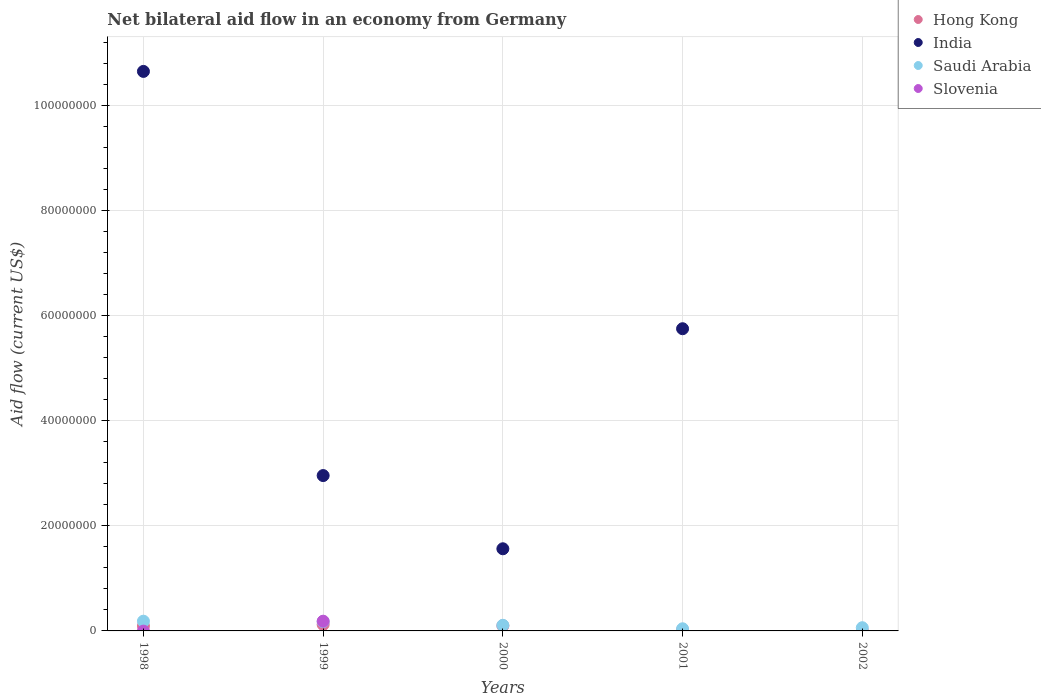What is the net bilateral aid flow in Saudi Arabia in 1998?
Offer a very short reply. 1.85e+06. Across all years, what is the maximum net bilateral aid flow in Hong Kong?
Ensure brevity in your answer.  1.22e+06. Across all years, what is the minimum net bilateral aid flow in Slovenia?
Make the answer very short. 0. What is the total net bilateral aid flow in Slovenia in the graph?
Your answer should be very brief. 1.85e+06. What is the difference between the net bilateral aid flow in Hong Kong in 1998 and that in 2002?
Keep it short and to the point. 9.10e+05. What is the difference between the net bilateral aid flow in India in 1999 and the net bilateral aid flow in Hong Kong in 2001?
Provide a succinct answer. 2.94e+07. In the year 1999, what is the difference between the net bilateral aid flow in Hong Kong and net bilateral aid flow in Slovenia?
Give a very brief answer. -6.30e+05. In how many years, is the net bilateral aid flow in India greater than 68000000 US$?
Your response must be concise. 1. What is the ratio of the net bilateral aid flow in Hong Kong in 1998 to that in 1999?
Keep it short and to the point. 0.75. Is the net bilateral aid flow in India in 1998 less than that in 1999?
Provide a short and direct response. No. What is the difference between the highest and the lowest net bilateral aid flow in Saudi Arabia?
Offer a terse response. 1.44e+06. In how many years, is the net bilateral aid flow in Hong Kong greater than the average net bilateral aid flow in Hong Kong taken over all years?
Give a very brief answer. 3. Is the sum of the net bilateral aid flow in Hong Kong in 1998 and 1999 greater than the maximum net bilateral aid flow in India across all years?
Provide a succinct answer. No. Is it the case that in every year, the sum of the net bilateral aid flow in Slovenia and net bilateral aid flow in Saudi Arabia  is greater than the sum of net bilateral aid flow in Hong Kong and net bilateral aid flow in India?
Provide a short and direct response. No. Is it the case that in every year, the sum of the net bilateral aid flow in India and net bilateral aid flow in Saudi Arabia  is greater than the net bilateral aid flow in Slovenia?
Provide a short and direct response. Yes. Is the net bilateral aid flow in Hong Kong strictly less than the net bilateral aid flow in Saudi Arabia over the years?
Make the answer very short. Yes. Are the values on the major ticks of Y-axis written in scientific E-notation?
Offer a terse response. No. Does the graph contain any zero values?
Your answer should be very brief. Yes. Does the graph contain grids?
Offer a terse response. Yes. Where does the legend appear in the graph?
Provide a short and direct response. Top right. What is the title of the graph?
Provide a succinct answer. Net bilateral aid flow in an economy from Germany. Does "Andorra" appear as one of the legend labels in the graph?
Provide a short and direct response. No. What is the Aid flow (current US$) in Hong Kong in 1998?
Your answer should be very brief. 9.20e+05. What is the Aid flow (current US$) of India in 1998?
Your response must be concise. 1.06e+08. What is the Aid flow (current US$) in Saudi Arabia in 1998?
Provide a short and direct response. 1.85e+06. What is the Aid flow (current US$) in Hong Kong in 1999?
Ensure brevity in your answer.  1.22e+06. What is the Aid flow (current US$) in India in 1999?
Provide a succinct answer. 2.96e+07. What is the Aid flow (current US$) in Saudi Arabia in 1999?
Your answer should be very brief. 1.76e+06. What is the Aid flow (current US$) in Slovenia in 1999?
Offer a very short reply. 1.85e+06. What is the Aid flow (current US$) in Hong Kong in 2000?
Ensure brevity in your answer.  9.80e+05. What is the Aid flow (current US$) in India in 2000?
Your answer should be compact. 1.56e+07. What is the Aid flow (current US$) in Saudi Arabia in 2000?
Your answer should be very brief. 1.07e+06. What is the Aid flow (current US$) in Slovenia in 2000?
Offer a terse response. 0. What is the Aid flow (current US$) in Hong Kong in 2001?
Provide a short and direct response. 1.50e+05. What is the Aid flow (current US$) of India in 2001?
Your response must be concise. 5.75e+07. What is the Aid flow (current US$) in Slovenia in 2001?
Keep it short and to the point. 0. What is the Aid flow (current US$) in Slovenia in 2002?
Your response must be concise. 0. Across all years, what is the maximum Aid flow (current US$) of Hong Kong?
Offer a very short reply. 1.22e+06. Across all years, what is the maximum Aid flow (current US$) of India?
Your answer should be compact. 1.06e+08. Across all years, what is the maximum Aid flow (current US$) of Saudi Arabia?
Offer a very short reply. 1.85e+06. Across all years, what is the maximum Aid flow (current US$) in Slovenia?
Offer a terse response. 1.85e+06. What is the total Aid flow (current US$) in Hong Kong in the graph?
Provide a succinct answer. 3.28e+06. What is the total Aid flow (current US$) of India in the graph?
Your answer should be compact. 2.09e+08. What is the total Aid flow (current US$) in Saudi Arabia in the graph?
Give a very brief answer. 5.70e+06. What is the total Aid flow (current US$) in Slovenia in the graph?
Your response must be concise. 1.85e+06. What is the difference between the Aid flow (current US$) in Hong Kong in 1998 and that in 1999?
Your answer should be very brief. -3.00e+05. What is the difference between the Aid flow (current US$) of India in 1998 and that in 1999?
Make the answer very short. 7.69e+07. What is the difference between the Aid flow (current US$) in Saudi Arabia in 1998 and that in 1999?
Provide a succinct answer. 9.00e+04. What is the difference between the Aid flow (current US$) in Hong Kong in 1998 and that in 2000?
Provide a succinct answer. -6.00e+04. What is the difference between the Aid flow (current US$) of India in 1998 and that in 2000?
Ensure brevity in your answer.  9.08e+07. What is the difference between the Aid flow (current US$) of Saudi Arabia in 1998 and that in 2000?
Offer a terse response. 7.80e+05. What is the difference between the Aid flow (current US$) in Hong Kong in 1998 and that in 2001?
Your response must be concise. 7.70e+05. What is the difference between the Aid flow (current US$) of India in 1998 and that in 2001?
Keep it short and to the point. 4.90e+07. What is the difference between the Aid flow (current US$) of Saudi Arabia in 1998 and that in 2001?
Offer a terse response. 1.44e+06. What is the difference between the Aid flow (current US$) in Hong Kong in 1998 and that in 2002?
Your answer should be compact. 9.10e+05. What is the difference between the Aid flow (current US$) of Saudi Arabia in 1998 and that in 2002?
Make the answer very short. 1.24e+06. What is the difference between the Aid flow (current US$) of India in 1999 and that in 2000?
Offer a terse response. 1.39e+07. What is the difference between the Aid flow (current US$) in Saudi Arabia in 1999 and that in 2000?
Provide a short and direct response. 6.90e+05. What is the difference between the Aid flow (current US$) in Hong Kong in 1999 and that in 2001?
Make the answer very short. 1.07e+06. What is the difference between the Aid flow (current US$) in India in 1999 and that in 2001?
Give a very brief answer. -2.79e+07. What is the difference between the Aid flow (current US$) of Saudi Arabia in 1999 and that in 2001?
Ensure brevity in your answer.  1.35e+06. What is the difference between the Aid flow (current US$) in Hong Kong in 1999 and that in 2002?
Provide a short and direct response. 1.21e+06. What is the difference between the Aid flow (current US$) of Saudi Arabia in 1999 and that in 2002?
Provide a short and direct response. 1.15e+06. What is the difference between the Aid flow (current US$) in Hong Kong in 2000 and that in 2001?
Your answer should be very brief. 8.30e+05. What is the difference between the Aid flow (current US$) of India in 2000 and that in 2001?
Make the answer very short. -4.19e+07. What is the difference between the Aid flow (current US$) in Hong Kong in 2000 and that in 2002?
Your answer should be very brief. 9.70e+05. What is the difference between the Aid flow (current US$) of Saudi Arabia in 2000 and that in 2002?
Your answer should be compact. 4.60e+05. What is the difference between the Aid flow (current US$) of Hong Kong in 2001 and that in 2002?
Offer a very short reply. 1.40e+05. What is the difference between the Aid flow (current US$) in Hong Kong in 1998 and the Aid flow (current US$) in India in 1999?
Provide a short and direct response. -2.86e+07. What is the difference between the Aid flow (current US$) of Hong Kong in 1998 and the Aid flow (current US$) of Saudi Arabia in 1999?
Your answer should be very brief. -8.40e+05. What is the difference between the Aid flow (current US$) in Hong Kong in 1998 and the Aid flow (current US$) in Slovenia in 1999?
Keep it short and to the point. -9.30e+05. What is the difference between the Aid flow (current US$) in India in 1998 and the Aid flow (current US$) in Saudi Arabia in 1999?
Your answer should be compact. 1.05e+08. What is the difference between the Aid flow (current US$) in India in 1998 and the Aid flow (current US$) in Slovenia in 1999?
Your answer should be compact. 1.05e+08. What is the difference between the Aid flow (current US$) of Saudi Arabia in 1998 and the Aid flow (current US$) of Slovenia in 1999?
Your response must be concise. 0. What is the difference between the Aid flow (current US$) of Hong Kong in 1998 and the Aid flow (current US$) of India in 2000?
Your answer should be compact. -1.47e+07. What is the difference between the Aid flow (current US$) in Hong Kong in 1998 and the Aid flow (current US$) in Saudi Arabia in 2000?
Give a very brief answer. -1.50e+05. What is the difference between the Aid flow (current US$) of India in 1998 and the Aid flow (current US$) of Saudi Arabia in 2000?
Offer a terse response. 1.05e+08. What is the difference between the Aid flow (current US$) in Hong Kong in 1998 and the Aid flow (current US$) in India in 2001?
Provide a short and direct response. -5.66e+07. What is the difference between the Aid flow (current US$) in Hong Kong in 1998 and the Aid flow (current US$) in Saudi Arabia in 2001?
Give a very brief answer. 5.10e+05. What is the difference between the Aid flow (current US$) in India in 1998 and the Aid flow (current US$) in Saudi Arabia in 2001?
Provide a succinct answer. 1.06e+08. What is the difference between the Aid flow (current US$) in India in 1998 and the Aid flow (current US$) in Saudi Arabia in 2002?
Make the answer very short. 1.06e+08. What is the difference between the Aid flow (current US$) of Hong Kong in 1999 and the Aid flow (current US$) of India in 2000?
Provide a short and direct response. -1.44e+07. What is the difference between the Aid flow (current US$) in Hong Kong in 1999 and the Aid flow (current US$) in Saudi Arabia in 2000?
Offer a terse response. 1.50e+05. What is the difference between the Aid flow (current US$) in India in 1999 and the Aid flow (current US$) in Saudi Arabia in 2000?
Make the answer very short. 2.85e+07. What is the difference between the Aid flow (current US$) of Hong Kong in 1999 and the Aid flow (current US$) of India in 2001?
Ensure brevity in your answer.  -5.63e+07. What is the difference between the Aid flow (current US$) in Hong Kong in 1999 and the Aid flow (current US$) in Saudi Arabia in 2001?
Offer a terse response. 8.10e+05. What is the difference between the Aid flow (current US$) in India in 1999 and the Aid flow (current US$) in Saudi Arabia in 2001?
Your response must be concise. 2.92e+07. What is the difference between the Aid flow (current US$) in India in 1999 and the Aid flow (current US$) in Saudi Arabia in 2002?
Your answer should be compact. 2.90e+07. What is the difference between the Aid flow (current US$) of Hong Kong in 2000 and the Aid flow (current US$) of India in 2001?
Your response must be concise. -5.65e+07. What is the difference between the Aid flow (current US$) of Hong Kong in 2000 and the Aid flow (current US$) of Saudi Arabia in 2001?
Offer a terse response. 5.70e+05. What is the difference between the Aid flow (current US$) in India in 2000 and the Aid flow (current US$) in Saudi Arabia in 2001?
Your answer should be very brief. 1.52e+07. What is the difference between the Aid flow (current US$) in Hong Kong in 2000 and the Aid flow (current US$) in Saudi Arabia in 2002?
Offer a very short reply. 3.70e+05. What is the difference between the Aid flow (current US$) of India in 2000 and the Aid flow (current US$) of Saudi Arabia in 2002?
Provide a succinct answer. 1.50e+07. What is the difference between the Aid flow (current US$) in Hong Kong in 2001 and the Aid flow (current US$) in Saudi Arabia in 2002?
Make the answer very short. -4.60e+05. What is the difference between the Aid flow (current US$) in India in 2001 and the Aid flow (current US$) in Saudi Arabia in 2002?
Give a very brief answer. 5.69e+07. What is the average Aid flow (current US$) of Hong Kong per year?
Provide a succinct answer. 6.56e+05. What is the average Aid flow (current US$) of India per year?
Ensure brevity in your answer.  4.18e+07. What is the average Aid flow (current US$) in Saudi Arabia per year?
Ensure brevity in your answer.  1.14e+06. In the year 1998, what is the difference between the Aid flow (current US$) in Hong Kong and Aid flow (current US$) in India?
Your answer should be very brief. -1.06e+08. In the year 1998, what is the difference between the Aid flow (current US$) in Hong Kong and Aid flow (current US$) in Saudi Arabia?
Provide a short and direct response. -9.30e+05. In the year 1998, what is the difference between the Aid flow (current US$) of India and Aid flow (current US$) of Saudi Arabia?
Give a very brief answer. 1.05e+08. In the year 1999, what is the difference between the Aid flow (current US$) of Hong Kong and Aid flow (current US$) of India?
Provide a succinct answer. -2.83e+07. In the year 1999, what is the difference between the Aid flow (current US$) of Hong Kong and Aid flow (current US$) of Saudi Arabia?
Provide a short and direct response. -5.40e+05. In the year 1999, what is the difference between the Aid flow (current US$) in Hong Kong and Aid flow (current US$) in Slovenia?
Your answer should be compact. -6.30e+05. In the year 1999, what is the difference between the Aid flow (current US$) in India and Aid flow (current US$) in Saudi Arabia?
Offer a very short reply. 2.78e+07. In the year 1999, what is the difference between the Aid flow (current US$) of India and Aid flow (current US$) of Slovenia?
Offer a very short reply. 2.77e+07. In the year 1999, what is the difference between the Aid flow (current US$) of Saudi Arabia and Aid flow (current US$) of Slovenia?
Keep it short and to the point. -9.00e+04. In the year 2000, what is the difference between the Aid flow (current US$) of Hong Kong and Aid flow (current US$) of India?
Your answer should be very brief. -1.46e+07. In the year 2000, what is the difference between the Aid flow (current US$) of Hong Kong and Aid flow (current US$) of Saudi Arabia?
Offer a very short reply. -9.00e+04. In the year 2000, what is the difference between the Aid flow (current US$) in India and Aid flow (current US$) in Saudi Arabia?
Your response must be concise. 1.46e+07. In the year 2001, what is the difference between the Aid flow (current US$) of Hong Kong and Aid flow (current US$) of India?
Provide a succinct answer. -5.74e+07. In the year 2001, what is the difference between the Aid flow (current US$) in Hong Kong and Aid flow (current US$) in Saudi Arabia?
Your response must be concise. -2.60e+05. In the year 2001, what is the difference between the Aid flow (current US$) in India and Aid flow (current US$) in Saudi Arabia?
Make the answer very short. 5.71e+07. In the year 2002, what is the difference between the Aid flow (current US$) in Hong Kong and Aid flow (current US$) in Saudi Arabia?
Give a very brief answer. -6.00e+05. What is the ratio of the Aid flow (current US$) of Hong Kong in 1998 to that in 1999?
Your response must be concise. 0.75. What is the ratio of the Aid flow (current US$) in India in 1998 to that in 1999?
Offer a very short reply. 3.6. What is the ratio of the Aid flow (current US$) of Saudi Arabia in 1998 to that in 1999?
Offer a very short reply. 1.05. What is the ratio of the Aid flow (current US$) in Hong Kong in 1998 to that in 2000?
Your answer should be very brief. 0.94. What is the ratio of the Aid flow (current US$) of India in 1998 to that in 2000?
Give a very brief answer. 6.81. What is the ratio of the Aid flow (current US$) of Saudi Arabia in 1998 to that in 2000?
Offer a very short reply. 1.73. What is the ratio of the Aid flow (current US$) in Hong Kong in 1998 to that in 2001?
Offer a terse response. 6.13. What is the ratio of the Aid flow (current US$) of India in 1998 to that in 2001?
Give a very brief answer. 1.85. What is the ratio of the Aid flow (current US$) in Saudi Arabia in 1998 to that in 2001?
Your answer should be compact. 4.51. What is the ratio of the Aid flow (current US$) of Hong Kong in 1998 to that in 2002?
Provide a short and direct response. 92. What is the ratio of the Aid flow (current US$) in Saudi Arabia in 1998 to that in 2002?
Offer a very short reply. 3.03. What is the ratio of the Aid flow (current US$) in Hong Kong in 1999 to that in 2000?
Your answer should be very brief. 1.24. What is the ratio of the Aid flow (current US$) in India in 1999 to that in 2000?
Your answer should be very brief. 1.89. What is the ratio of the Aid flow (current US$) in Saudi Arabia in 1999 to that in 2000?
Keep it short and to the point. 1.64. What is the ratio of the Aid flow (current US$) of Hong Kong in 1999 to that in 2001?
Your answer should be compact. 8.13. What is the ratio of the Aid flow (current US$) in India in 1999 to that in 2001?
Your response must be concise. 0.51. What is the ratio of the Aid flow (current US$) of Saudi Arabia in 1999 to that in 2001?
Provide a short and direct response. 4.29. What is the ratio of the Aid flow (current US$) in Hong Kong in 1999 to that in 2002?
Provide a short and direct response. 122. What is the ratio of the Aid flow (current US$) of Saudi Arabia in 1999 to that in 2002?
Keep it short and to the point. 2.89. What is the ratio of the Aid flow (current US$) of Hong Kong in 2000 to that in 2001?
Make the answer very short. 6.53. What is the ratio of the Aid flow (current US$) of India in 2000 to that in 2001?
Your response must be concise. 0.27. What is the ratio of the Aid flow (current US$) of Saudi Arabia in 2000 to that in 2001?
Your answer should be very brief. 2.61. What is the ratio of the Aid flow (current US$) of Hong Kong in 2000 to that in 2002?
Provide a short and direct response. 98. What is the ratio of the Aid flow (current US$) in Saudi Arabia in 2000 to that in 2002?
Provide a short and direct response. 1.75. What is the ratio of the Aid flow (current US$) of Hong Kong in 2001 to that in 2002?
Your answer should be compact. 15. What is the ratio of the Aid flow (current US$) of Saudi Arabia in 2001 to that in 2002?
Your answer should be very brief. 0.67. What is the difference between the highest and the second highest Aid flow (current US$) in Hong Kong?
Keep it short and to the point. 2.40e+05. What is the difference between the highest and the second highest Aid flow (current US$) in India?
Your answer should be compact. 4.90e+07. What is the difference between the highest and the second highest Aid flow (current US$) in Saudi Arabia?
Make the answer very short. 9.00e+04. What is the difference between the highest and the lowest Aid flow (current US$) of Hong Kong?
Offer a terse response. 1.21e+06. What is the difference between the highest and the lowest Aid flow (current US$) in India?
Make the answer very short. 1.06e+08. What is the difference between the highest and the lowest Aid flow (current US$) of Saudi Arabia?
Your answer should be compact. 1.44e+06. What is the difference between the highest and the lowest Aid flow (current US$) in Slovenia?
Keep it short and to the point. 1.85e+06. 